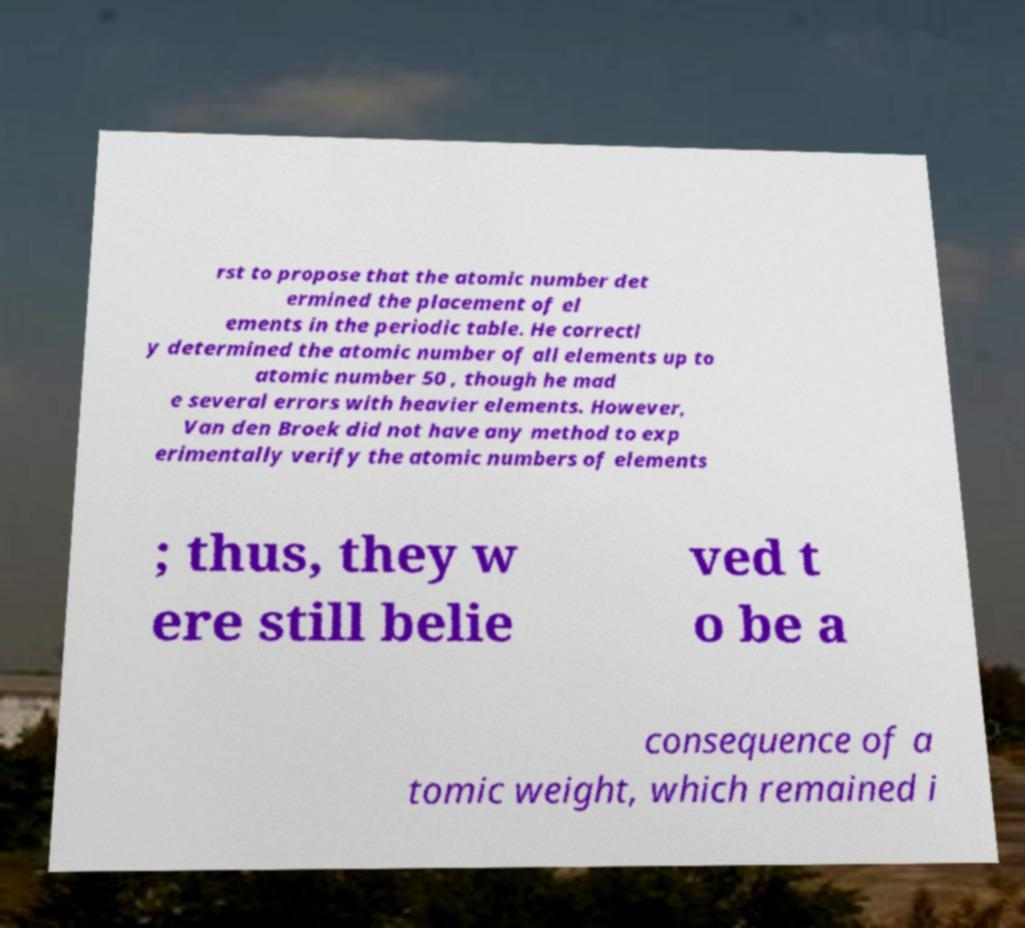There's text embedded in this image that I need extracted. Can you transcribe it verbatim? rst to propose that the atomic number det ermined the placement of el ements in the periodic table. He correctl y determined the atomic number of all elements up to atomic number 50 , though he mad e several errors with heavier elements. However, Van den Broek did not have any method to exp erimentally verify the atomic numbers of elements ; thus, they w ere still belie ved t o be a consequence of a tomic weight, which remained i 